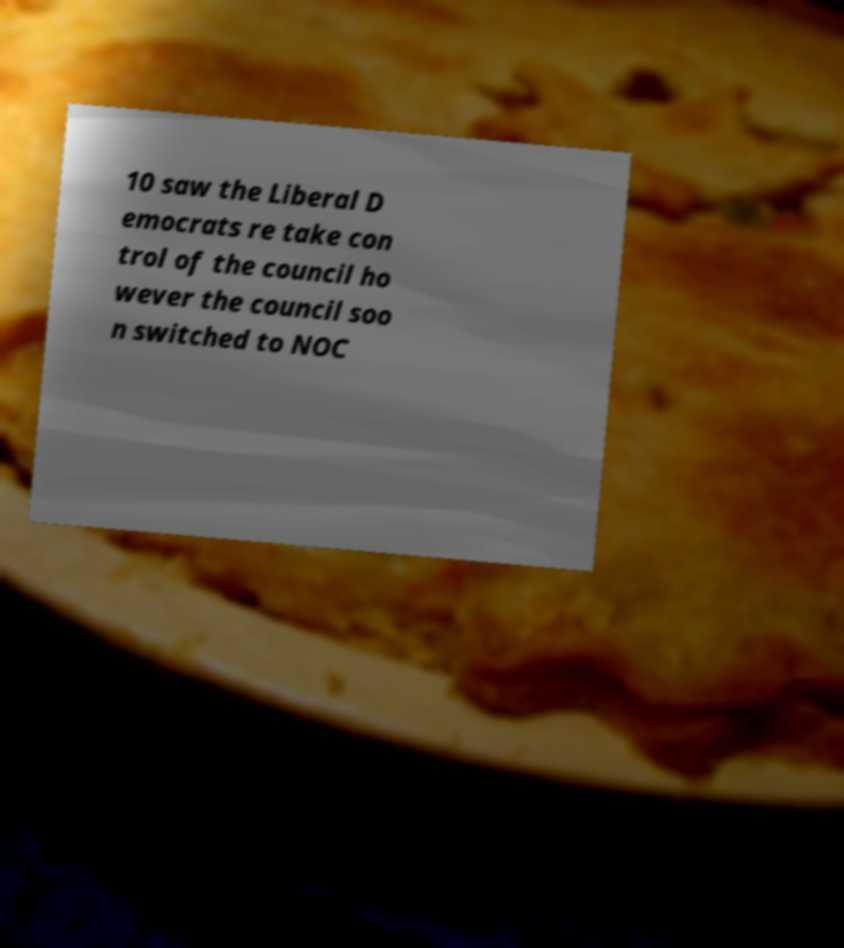Please identify and transcribe the text found in this image. 10 saw the Liberal D emocrats re take con trol of the council ho wever the council soo n switched to NOC 